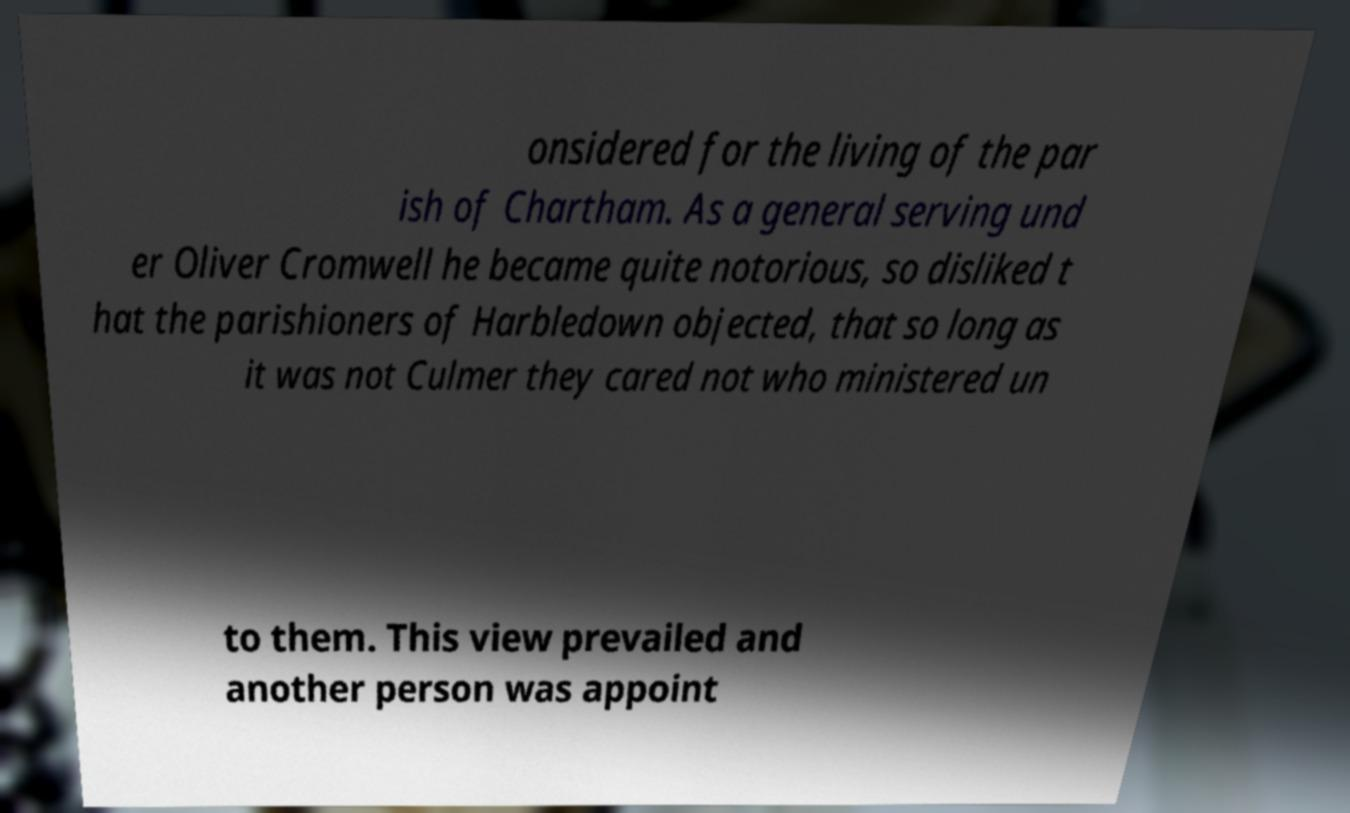Can you read and provide the text displayed in the image?This photo seems to have some interesting text. Can you extract and type it out for me? onsidered for the living of the par ish of Chartham. As a general serving und er Oliver Cromwell he became quite notorious, so disliked t hat the parishioners of Harbledown objected, that so long as it was not Culmer they cared not who ministered un to them. This view prevailed and another person was appoint 